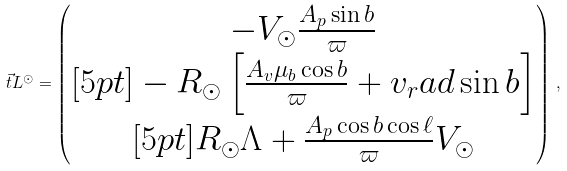Convert formula to latex. <formula><loc_0><loc_0><loc_500><loc_500>\vec { t } { L } ^ { \odot } = \begin{pmatrix} - V _ { \odot } \frac { A _ { p } \sin b } { \varpi } \\ [ 5 p t ] - R _ { \odot } \left [ \frac { A _ { v } \mu _ { b } \cos b } { \varpi } + v _ { r } a d \sin b \right ] \\ [ 5 p t ] R _ { \odot } \Lambda + \frac { A _ { p } \cos b \cos \ell } { \varpi } V _ { \odot } \end{pmatrix} \, , \\</formula> 